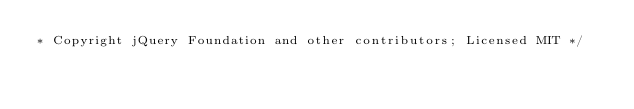<code> <loc_0><loc_0><loc_500><loc_500><_CSS_>* Copyright jQuery Foundation and other contributors; Licensed MIT */
</code> 